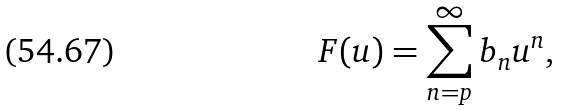Convert formula to latex. <formula><loc_0><loc_0><loc_500><loc_500>F ( u ) = \sum _ { n = p } ^ { \infty } b _ { n } u ^ { n } ,</formula> 